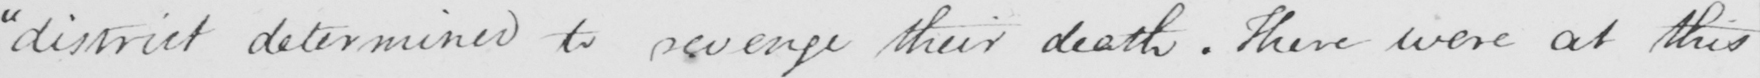Can you tell me what this handwritten text says? " district determined to revenge their death . There were at this 